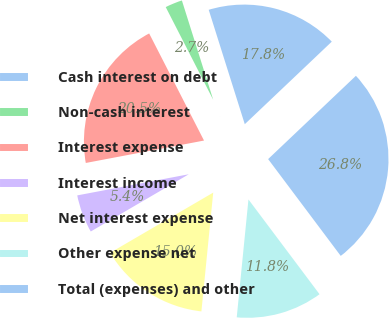Convert chart. <chart><loc_0><loc_0><loc_500><loc_500><pie_chart><fcel>Cash interest on debt<fcel>Non-cash interest<fcel>Interest expense<fcel>Interest income<fcel>Net interest expense<fcel>Other expense net<fcel>Total (expenses) and other<nl><fcel>17.78%<fcel>2.67%<fcel>20.45%<fcel>5.43%<fcel>15.01%<fcel>11.82%<fcel>26.84%<nl></chart> 